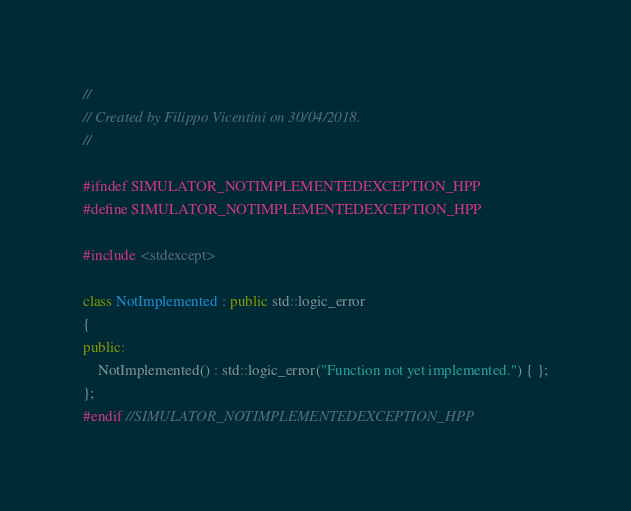<code> <loc_0><loc_0><loc_500><loc_500><_C++_>//
// Created by Filippo Vicentini on 30/04/2018.
//

#ifndef SIMULATOR_NOTIMPLEMENTEDEXCEPTION_HPP
#define SIMULATOR_NOTIMPLEMENTEDEXCEPTION_HPP

#include <stdexcept>

class NotImplemented : public std::logic_error
{
public:
    NotImplemented() : std::logic_error("Function not yet implemented.") { };
};
#endif //SIMULATOR_NOTIMPLEMENTEDEXCEPTION_HPP
</code> 